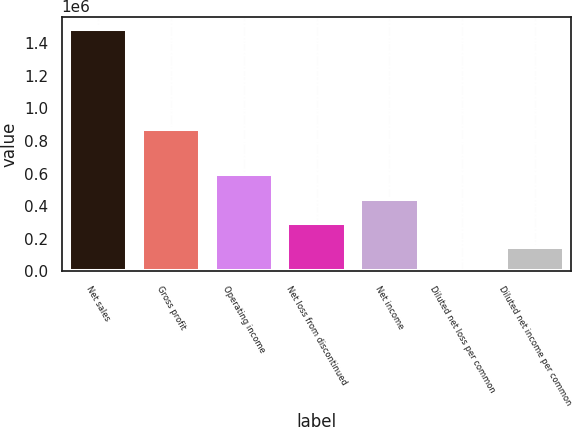<chart> <loc_0><loc_0><loc_500><loc_500><bar_chart><fcel>Net sales<fcel>Gross profit<fcel>Operating income<fcel>Net loss from discontinued<fcel>Net income<fcel>Diluted net loss per common<fcel>Diluted net income per common<nl><fcel>1.4872e+06<fcel>874436<fcel>594882<fcel>297441<fcel>446162<fcel>0.05<fcel>148721<nl></chart> 